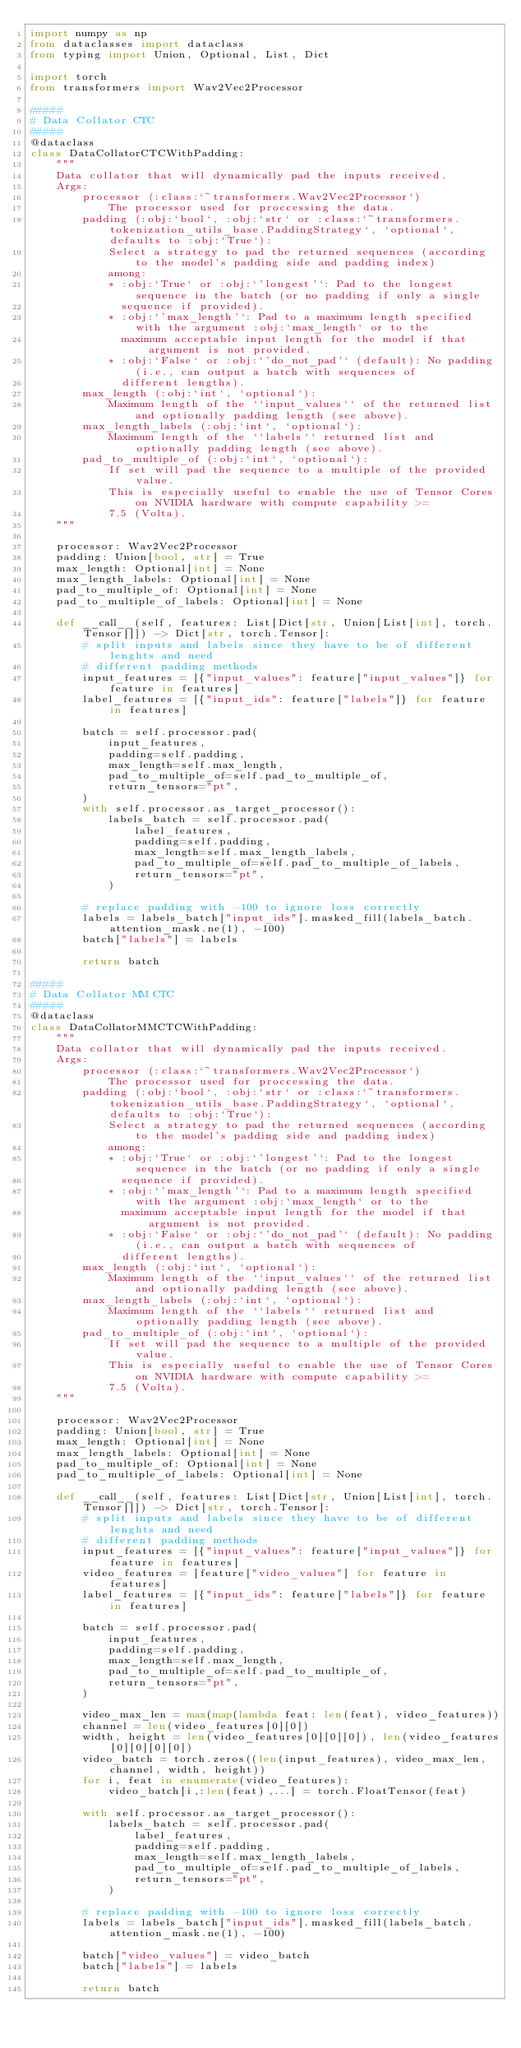<code> <loc_0><loc_0><loc_500><loc_500><_Python_>import numpy as np
from dataclasses import dataclass
from typing import Union, Optional, List, Dict

import torch
from transformers import Wav2Vec2Processor

#####
# Data Collator CTC
#####
@dataclass
class DataCollatorCTCWithPadding:
    """
    Data collator that will dynamically pad the inputs received.
    Args:
        processor (:class:`~transformers.Wav2Vec2Processor`)
            The processor used for proccessing the data.
        padding (:obj:`bool`, :obj:`str` or :class:`~transformers.tokenization_utils_base.PaddingStrategy`, `optional`, defaults to :obj:`True`):
            Select a strategy to pad the returned sequences (according to the model's padding side and padding index)
            among:
            * :obj:`True` or :obj:`'longest'`: Pad to the longest sequence in the batch (or no padding if only a single
              sequence if provided).
            * :obj:`'max_length'`: Pad to a maximum length specified with the argument :obj:`max_length` or to the
              maximum acceptable input length for the model if that argument is not provided.
            * :obj:`False` or :obj:`'do_not_pad'` (default): No padding (i.e., can output a batch with sequences of
              different lengths).
        max_length (:obj:`int`, `optional`):
            Maximum length of the ``input_values`` of the returned list and optionally padding length (see above).
        max_length_labels (:obj:`int`, `optional`):
            Maximum length of the ``labels`` returned list and optionally padding length (see above).
        pad_to_multiple_of (:obj:`int`, `optional`):
            If set will pad the sequence to a multiple of the provided value.
            This is especially useful to enable the use of Tensor Cores on NVIDIA hardware with compute capability >=
            7.5 (Volta).
    """

    processor: Wav2Vec2Processor
    padding: Union[bool, str] = True
    max_length: Optional[int] = None
    max_length_labels: Optional[int] = None
    pad_to_multiple_of: Optional[int] = None
    pad_to_multiple_of_labels: Optional[int] = None

    def __call__(self, features: List[Dict[str, Union[List[int], torch.Tensor]]]) -> Dict[str, torch.Tensor]:
        # split inputs and labels since they have to be of different lenghts and need
        # different padding methods
        input_features = [{"input_values": feature["input_values"]} for feature in features]
        label_features = [{"input_ids": feature["labels"]} for feature in features]

        batch = self.processor.pad(
            input_features,
            padding=self.padding,
            max_length=self.max_length,
            pad_to_multiple_of=self.pad_to_multiple_of,
            return_tensors="pt",
        )
        with self.processor.as_target_processor():
            labels_batch = self.processor.pad(
                label_features,
                padding=self.padding,
                max_length=self.max_length_labels,
                pad_to_multiple_of=self.pad_to_multiple_of_labels,
                return_tensors="pt",
            )

        # replace padding with -100 to ignore loss correctly
        labels = labels_batch["input_ids"].masked_fill(labels_batch.attention_mask.ne(1), -100)
        batch["labels"] = labels

        return batch
    
#####
# Data Collator MM CTC
#####
@dataclass
class DataCollatorMMCTCWithPadding:
    """
    Data collator that will dynamically pad the inputs received.
    Args:
        processor (:class:`~transformers.Wav2Vec2Processor`)
            The processor used for proccessing the data.
        padding (:obj:`bool`, :obj:`str` or :class:`~transformers.tokenization_utils_base.PaddingStrategy`, `optional`, defaults to :obj:`True`):
            Select a strategy to pad the returned sequences (according to the model's padding side and padding index)
            among:
            * :obj:`True` or :obj:`'longest'`: Pad to the longest sequence in the batch (or no padding if only a single
              sequence if provided).
            * :obj:`'max_length'`: Pad to a maximum length specified with the argument :obj:`max_length` or to the
              maximum acceptable input length for the model if that argument is not provided.
            * :obj:`False` or :obj:`'do_not_pad'` (default): No padding (i.e., can output a batch with sequences of
              different lengths).
        max_length (:obj:`int`, `optional`):
            Maximum length of the ``input_values`` of the returned list and optionally padding length (see above).
        max_length_labels (:obj:`int`, `optional`):
            Maximum length of the ``labels`` returned list and optionally padding length (see above).
        pad_to_multiple_of (:obj:`int`, `optional`):
            If set will pad the sequence to a multiple of the provided value.
            This is especially useful to enable the use of Tensor Cores on NVIDIA hardware with compute capability >=
            7.5 (Volta).
    """

    processor: Wav2Vec2Processor
    padding: Union[bool, str] = True
    max_length: Optional[int] = None
    max_length_labels: Optional[int] = None
    pad_to_multiple_of: Optional[int] = None
    pad_to_multiple_of_labels: Optional[int] = None

    def __call__(self, features: List[Dict[str, Union[List[int], torch.Tensor]]]) -> Dict[str, torch.Tensor]:
        # split inputs and labels since they have to be of different lenghts and need
        # different padding methods
        input_features = [{"input_values": feature["input_values"]} for feature in features]
        video_features = [feature["video_values"] for feature in features]
        label_features = [{"input_ids": feature["labels"]} for feature in features]

        batch = self.processor.pad(
            input_features,
            padding=self.padding,
            max_length=self.max_length,
            pad_to_multiple_of=self.pad_to_multiple_of,
            return_tensors="pt",
        )
        
        video_max_len = max(map(lambda feat: len(feat), video_features))
        channel = len(video_features[0][0])
        width, height = len(video_features[0][0][0]), len(video_features[0][0][0][0])
        video_batch = torch.zeros((len(input_features), video_max_len, channel, width, height))
        for i, feat in enumerate(video_features):
            video_batch[i,:len(feat),...] = torch.FloatTensor(feat)
        
        with self.processor.as_target_processor():
            labels_batch = self.processor.pad(
                label_features,
                padding=self.padding,
                max_length=self.max_length_labels,
                pad_to_multiple_of=self.pad_to_multiple_of_labels,
                return_tensors="pt",
            )

        # replace padding with -100 to ignore loss correctly
        labels = labels_batch["input_ids"].masked_fill(labels_batch.attention_mask.ne(1), -100)

        batch["video_values"] = video_batch
        batch["labels"] = labels

        return batch</code> 